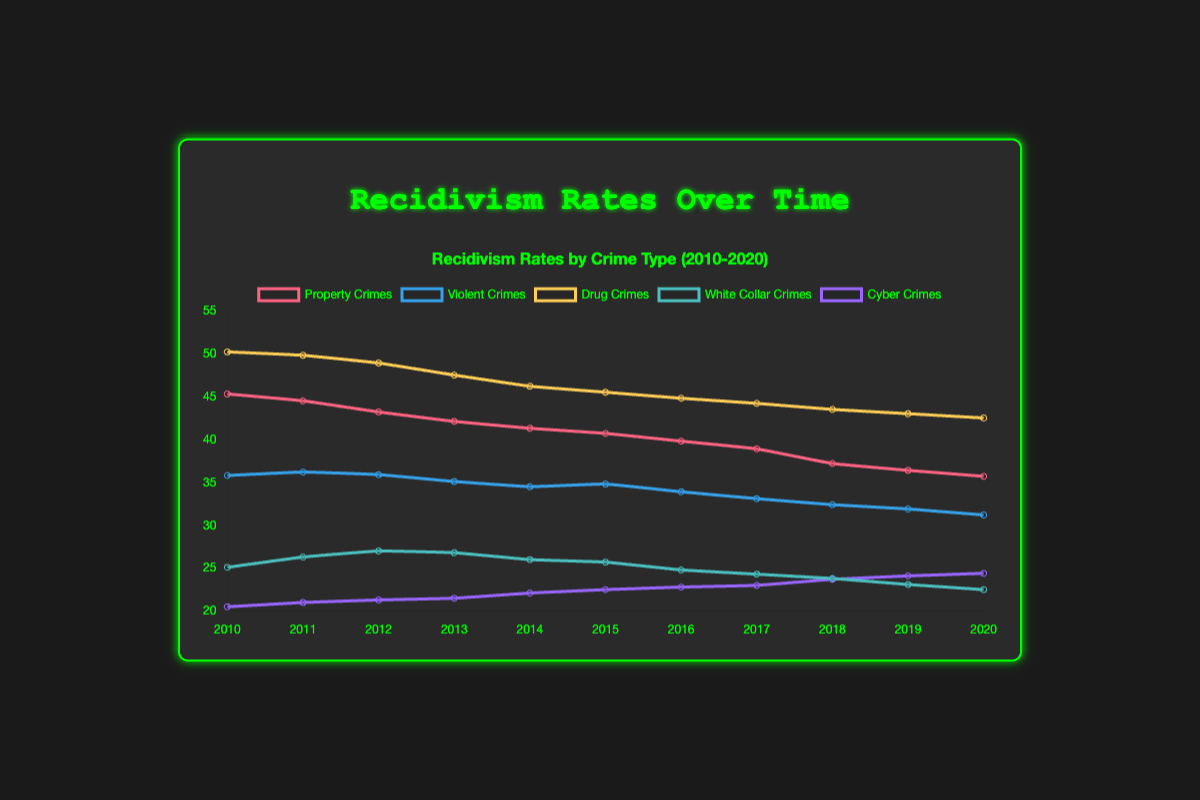What is the highest recidivism rate for any crime type in 2010? In the year 2010, the highest recidivism rate can be determined by looking at the data points for that year. Property crimes are at 45.3%, violent crimes at 35.8%, drug crimes at 50.2%, white-collar crimes at 25.1%, and cyber crimes at 20.5%. The highest value among these is 50.2% for drug crimes.
Answer: 50.2% Which crime type had the lowest recidivism rate in 2020? To find the lowest recidivism rate in 2020, examine the data points for each crime type: property crimes at 35.7%, violent crimes at 31.2%, drug crimes at 42.5%, white-collar crimes at 22.5%, and cyber crimes at 24.4%. The lowest value is 22.5% for white-collar crimes.
Answer: White-collar crimes By how much did the recidivism rate for violent crimes change from 2010 to 2020? To find the change, subtract the recidivism rate in 2020 from that in 2010. For violent crimes, the rate was 35.8% in 2010 and 31.2% in 2020. The change is 35.8% - 31.2% = 4.6%.
Answer: 4.6% Which crime type showed the most consistent decrease in recidivism rates from 2010 to 2020? The most consistent decrease can be identified by examining the trends for each crime type. Property crimes decreased from 45.3% to 35.7%, violent crimes from 35.8% to 31.2%, drug crimes from 50.2% to 42.5%, white-collar crimes from 25.1% to 22.5%, and cyber crimes from 20.5% to 24.4%. Property crimes show the most consistent decrease.
Answer: Property crimes What is the average recidivism rate for drug crimes from 2010 to 2020? To calculate the average, sum the recidivism rates for drug crimes over the years and divide by the number of years. The sum is 50.2 + 49.8 + 48.9 + 47.5 + 46.2 + 45.5 + 44.8 + 44.2 + 43.5 + 43.0 + 42.5 = 496.1. Dividing this by 11 years gives an average of 496.1 / 11 ≈ 45.1%.
Answer: 45.1% Which crime type had the greatest increase in recidivism rate between any two consecutive years? To find the greatest increase, compare the year-to-year differences for each crime type. The biggest rise is between 2013 and 2014 for cyber crimes, increasing from 21.5% to 22.1%, which is an increase of 0.6%.
Answer: Cyber crimes What was the recidivism rate for drug crimes in 2016 compared to white-collar crimes? To compare the rates in 2016, look at the recidivism rates: drug crimes have a rate of 44.8% and white-collar crimes are at 24.8%. Drug crimes have a higher recidivism rate.
Answer: Drug crimes Which crime type had the smallest change in recidivism rate from 2010 to 2020? By calculating the absolute difference for each crime type over the ten years, property crimes decreased by 9.6%, violent crimes by 4.6%, drug crimes by 7.7%, white-collar crimes by 2.6%, and cyber crimes increased by 3.9%. White-collar crimes had the smallest change.
Answer: White-collar crimes What year did cyber crimes have the highest recidivism rate? Examining the data points for cyber crimes from 2010 to 2020, the highest rate is in 2020 with 24.4%.
Answer: 2020 